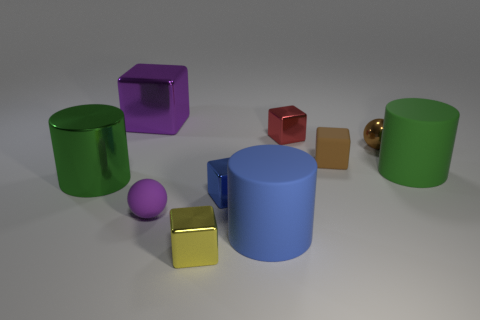Subtract all green cylinders. How many were subtracted if there are1green cylinders left? 1 Subtract all purple spheres. How many spheres are left? 1 Subtract all metal cylinders. How many cylinders are left? 2 Subtract 1 brown spheres. How many objects are left? 9 Subtract all cylinders. How many objects are left? 7 Subtract 2 cylinders. How many cylinders are left? 1 Subtract all yellow blocks. Subtract all cyan balls. How many blocks are left? 4 Subtract all cyan spheres. How many purple cylinders are left? 0 Subtract all tiny spheres. Subtract all big gray shiny spheres. How many objects are left? 8 Add 9 purple cubes. How many purple cubes are left? 10 